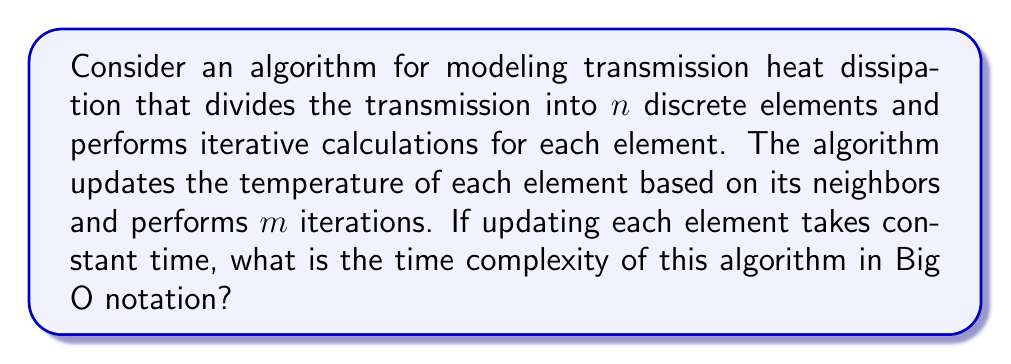Help me with this question. To determine the time complexity of this algorithm, we need to analyze the number of operations performed:

1. The transmission is divided into $n$ discrete elements.

2. For each iteration (total of $m$ iterations):
   - We update each of the $n$ elements.
   - Updating each element takes constant time, let's call this $c$.

3. The total number of operations can be expressed as:
   $$T(n,m) = m \cdot n \cdot c$$

4. Since $c$ is a constant, we can simplify this to:
   $$T(n,m) = O(m \cdot n)$$

5. In Big O notation, we typically express complexity in terms of the input size. Here, both $n$ and $m$ are input parameters that can vary.

6. The worst-case scenario (and thus the upper bound) would be when both $n$ and $m$ are large. Therefore, we keep both in our Big O expression.

7. We cannot simplify this further without additional information about the relationship between $n$ and $m$.

Therefore, the time complexity of this algorithm is $O(m \cdot n)$.
Answer: $O(m \cdot n)$ 